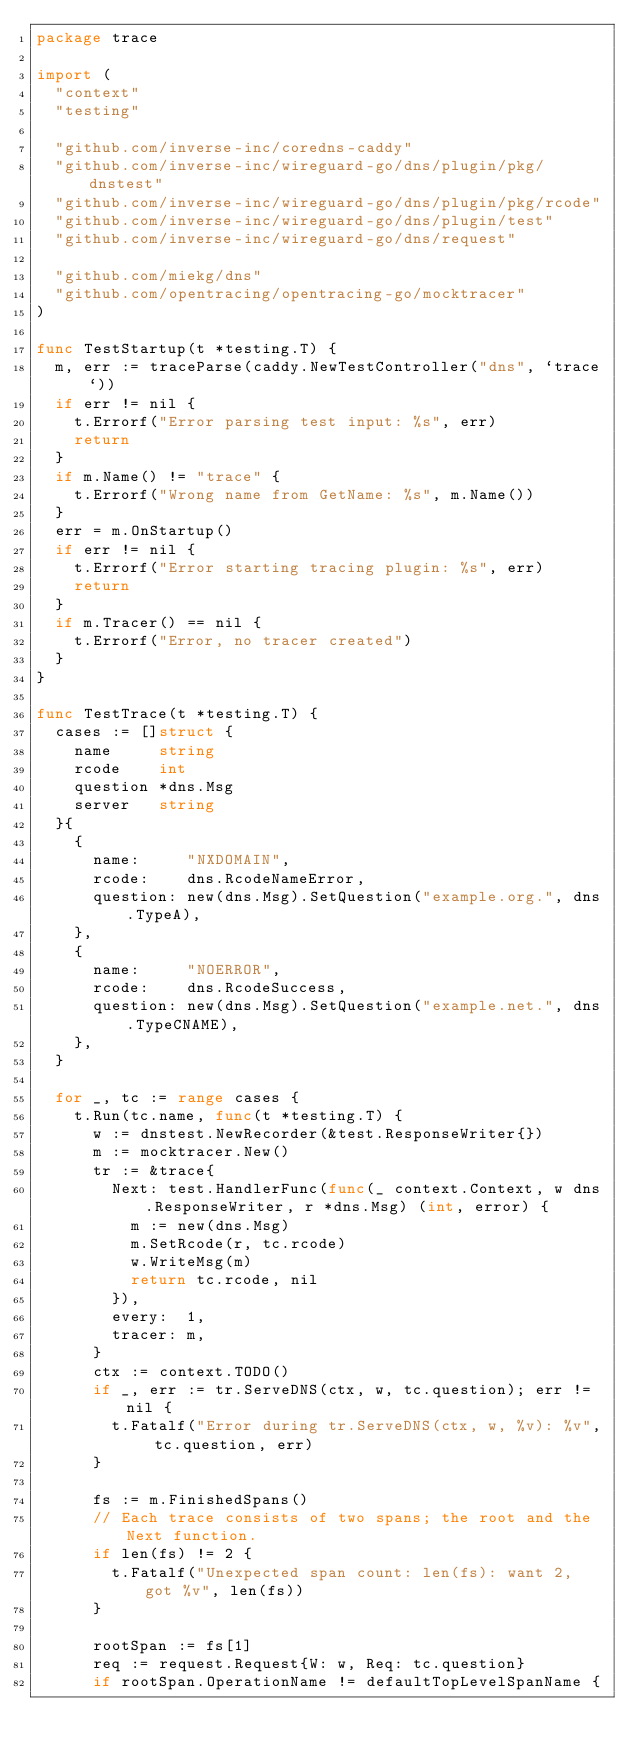<code> <loc_0><loc_0><loc_500><loc_500><_Go_>package trace

import (
	"context"
	"testing"

	"github.com/inverse-inc/coredns-caddy"
	"github.com/inverse-inc/wireguard-go/dns/plugin/pkg/dnstest"
	"github.com/inverse-inc/wireguard-go/dns/plugin/pkg/rcode"
	"github.com/inverse-inc/wireguard-go/dns/plugin/test"
	"github.com/inverse-inc/wireguard-go/dns/request"

	"github.com/miekg/dns"
	"github.com/opentracing/opentracing-go/mocktracer"
)

func TestStartup(t *testing.T) {
	m, err := traceParse(caddy.NewTestController("dns", `trace`))
	if err != nil {
		t.Errorf("Error parsing test input: %s", err)
		return
	}
	if m.Name() != "trace" {
		t.Errorf("Wrong name from GetName: %s", m.Name())
	}
	err = m.OnStartup()
	if err != nil {
		t.Errorf("Error starting tracing plugin: %s", err)
		return
	}
	if m.Tracer() == nil {
		t.Errorf("Error, no tracer created")
	}
}

func TestTrace(t *testing.T) {
	cases := []struct {
		name     string
		rcode    int
		question *dns.Msg
		server   string
	}{
		{
			name:     "NXDOMAIN",
			rcode:    dns.RcodeNameError,
			question: new(dns.Msg).SetQuestion("example.org.", dns.TypeA),
		},
		{
			name:     "NOERROR",
			rcode:    dns.RcodeSuccess,
			question: new(dns.Msg).SetQuestion("example.net.", dns.TypeCNAME),
		},
	}

	for _, tc := range cases {
		t.Run(tc.name, func(t *testing.T) {
			w := dnstest.NewRecorder(&test.ResponseWriter{})
			m := mocktracer.New()
			tr := &trace{
				Next: test.HandlerFunc(func(_ context.Context, w dns.ResponseWriter, r *dns.Msg) (int, error) {
					m := new(dns.Msg)
					m.SetRcode(r, tc.rcode)
					w.WriteMsg(m)
					return tc.rcode, nil
				}),
				every:  1,
				tracer: m,
			}
			ctx := context.TODO()
			if _, err := tr.ServeDNS(ctx, w, tc.question); err != nil {
				t.Fatalf("Error during tr.ServeDNS(ctx, w, %v): %v", tc.question, err)
			}

			fs := m.FinishedSpans()
			// Each trace consists of two spans; the root and the Next function.
			if len(fs) != 2 {
				t.Fatalf("Unexpected span count: len(fs): want 2, got %v", len(fs))
			}

			rootSpan := fs[1]
			req := request.Request{W: w, Req: tc.question}
			if rootSpan.OperationName != defaultTopLevelSpanName {</code> 